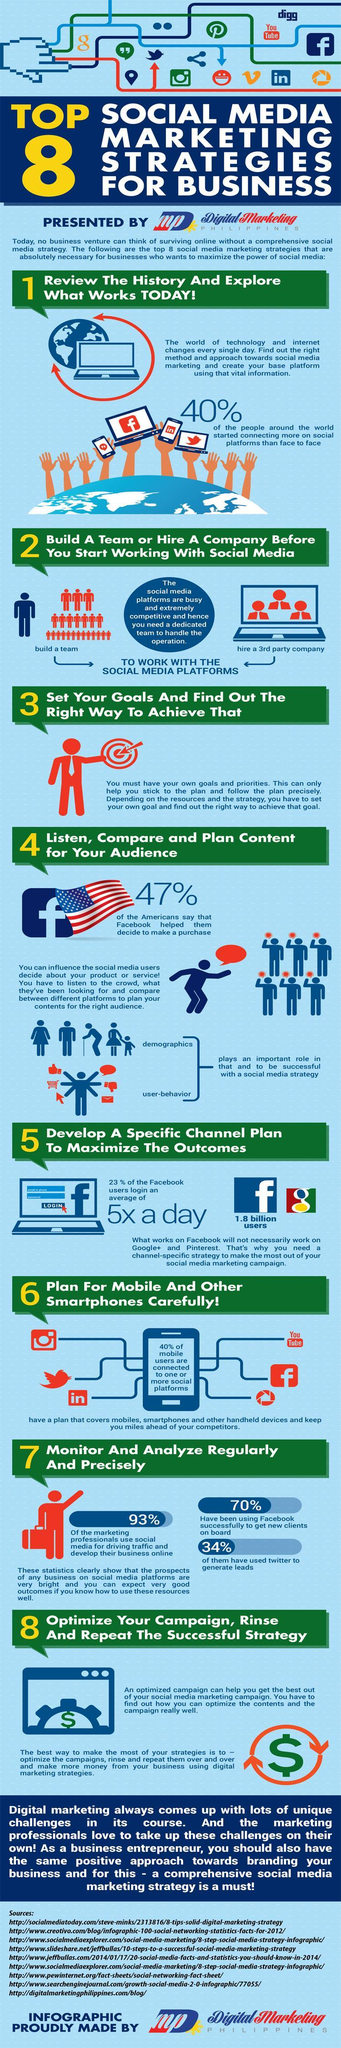Which social media platforms are used for generate prospects online?
Answer the question with a short phrase. Facebook, Twitter How many social media apps are used regularly on mobiles? 6 What percentage of marketing professionals do not use social media for marketing? 7% 